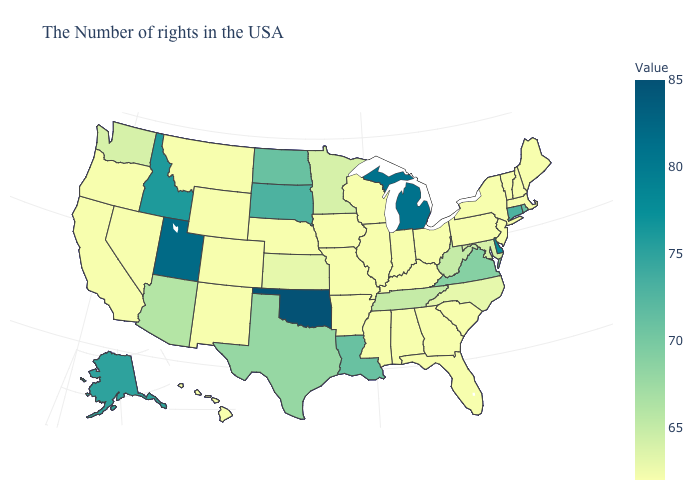Among the states that border Tennessee , does Alabama have the highest value?
Short answer required. No. Which states hav the highest value in the Northeast?
Give a very brief answer. Connecticut. Does Tennessee have the lowest value in the USA?
Answer briefly. No. Among the states that border Alabama , does Florida have the highest value?
Answer briefly. No. 